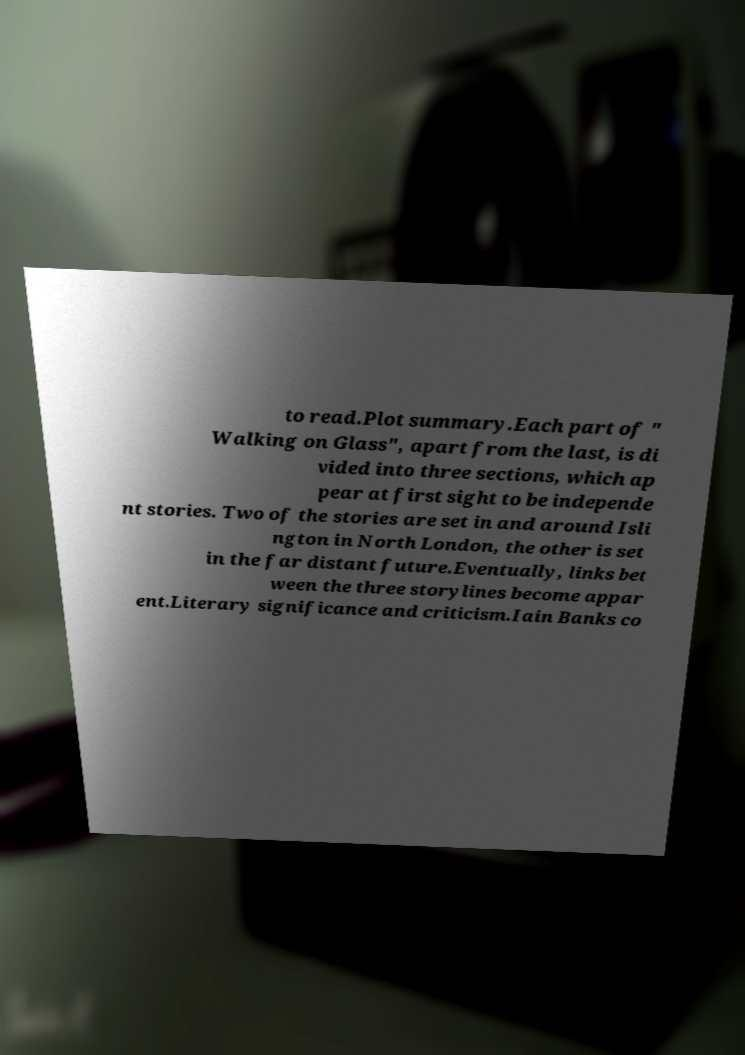For documentation purposes, I need the text within this image transcribed. Could you provide that? to read.Plot summary.Each part of " Walking on Glass", apart from the last, is di vided into three sections, which ap pear at first sight to be independe nt stories. Two of the stories are set in and around Isli ngton in North London, the other is set in the far distant future.Eventually, links bet ween the three storylines become appar ent.Literary significance and criticism.Iain Banks co 